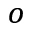Convert formula to latex. <formula><loc_0><loc_0><loc_500><loc_500>^ { o }</formula> 